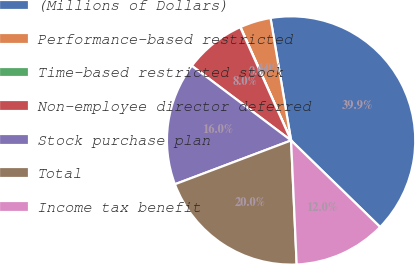Convert chart. <chart><loc_0><loc_0><loc_500><loc_500><pie_chart><fcel>(Millions of Dollars)<fcel>Performance-based restricted<fcel>Time-based restricted stock<fcel>Non-employee director deferred<fcel>Stock purchase plan<fcel>Total<fcel>Income tax benefit<nl><fcel>39.93%<fcel>4.03%<fcel>0.04%<fcel>8.02%<fcel>16.0%<fcel>19.98%<fcel>12.01%<nl></chart> 